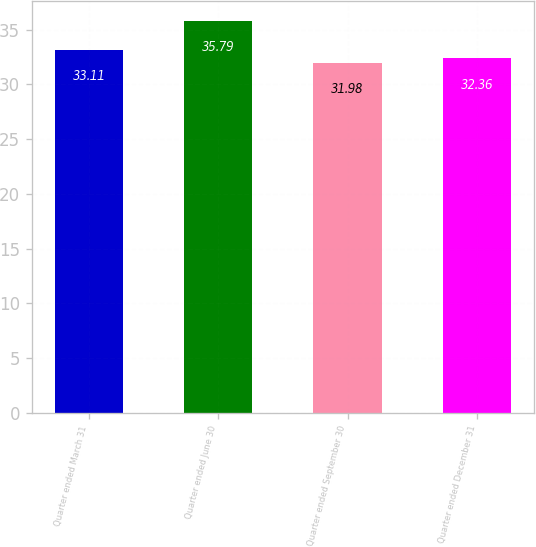Convert chart to OTSL. <chart><loc_0><loc_0><loc_500><loc_500><bar_chart><fcel>Quarter ended March 31<fcel>Quarter ended June 30<fcel>Quarter ended September 30<fcel>Quarter ended December 31<nl><fcel>33.11<fcel>35.79<fcel>31.98<fcel>32.36<nl></chart> 